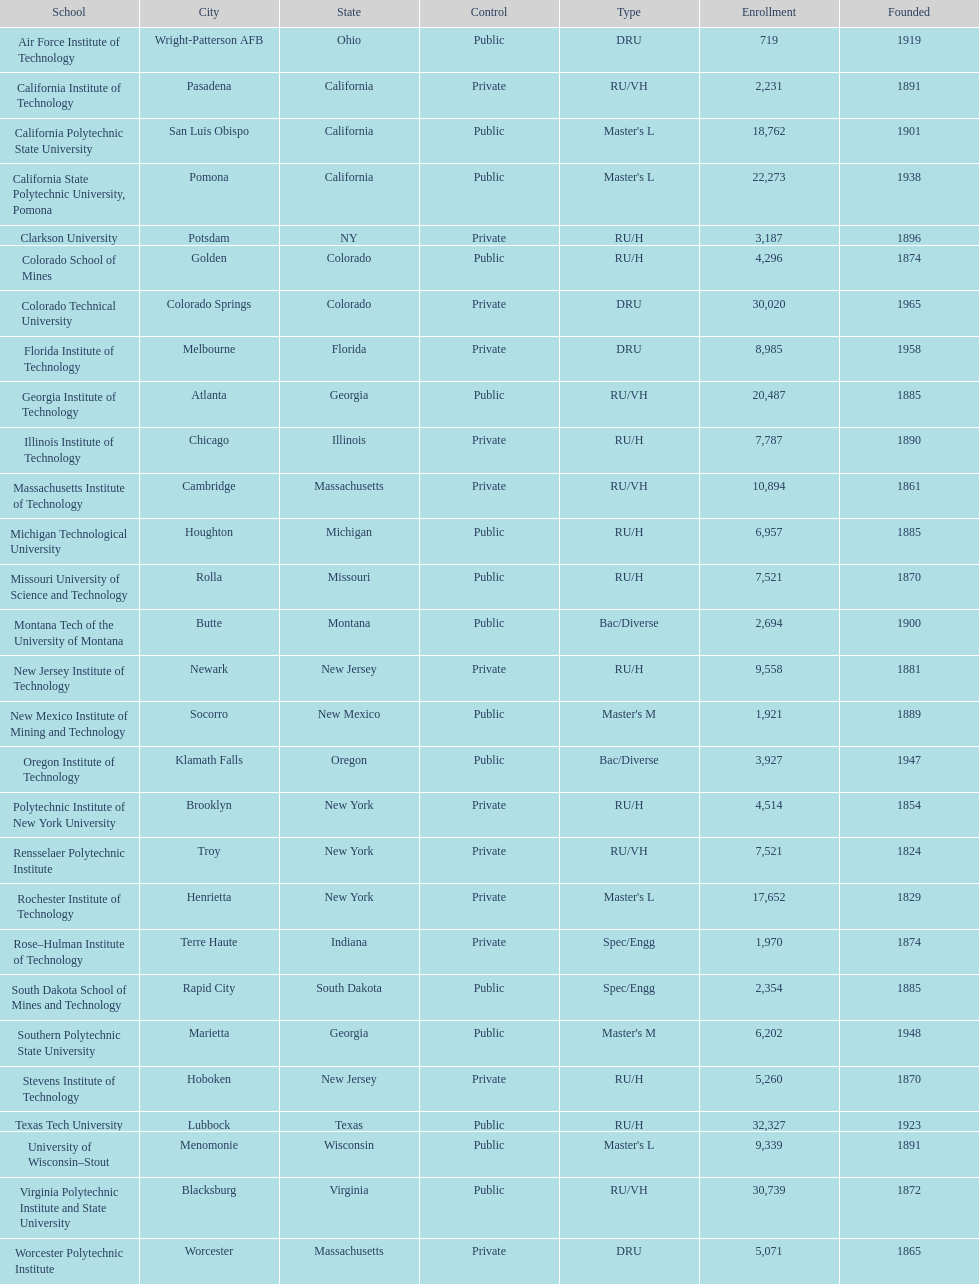Which of the universities was founded first? Rensselaer Polytechnic Institute. 